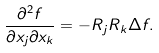<formula> <loc_0><loc_0><loc_500><loc_500>\frac { \partial ^ { 2 } f } { \partial x _ { j } \partial x _ { k } } = - R _ { j } R _ { k } \Delta f .</formula> 